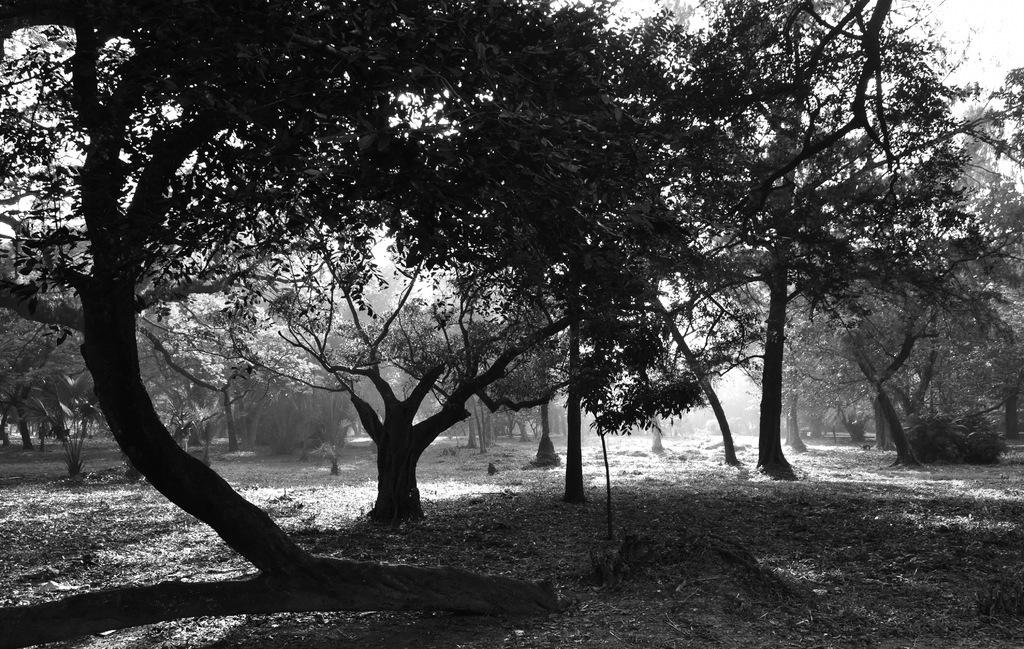What is the color scheme of the image? The image is black and white. What type of landscape is depicted in the image? There are plenty of trees on the land in the image. Can you see anyone kicking a soccer ball in the image? There is no soccer ball or person kicking it present in the image. What type of appliance can be seen plugged into the wall in the image? There is no appliance present in the image, as it is a black and white landscape with plenty of trees. 